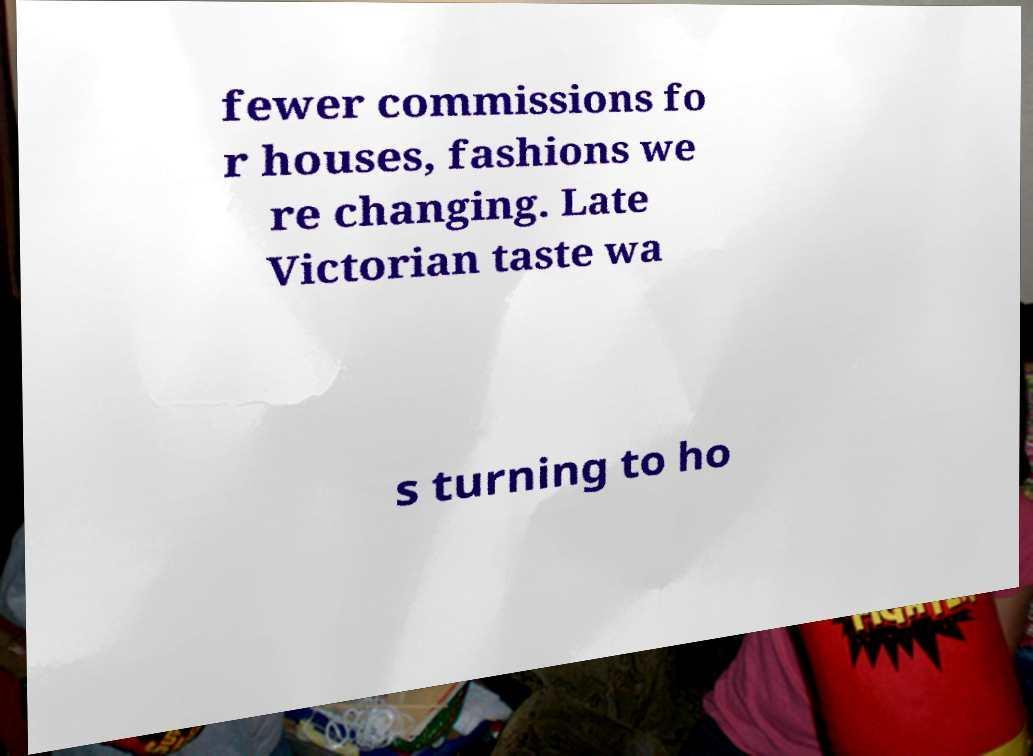Please identify and transcribe the text found in this image. fewer commissions fo r houses, fashions we re changing. Late Victorian taste wa s turning to ho 